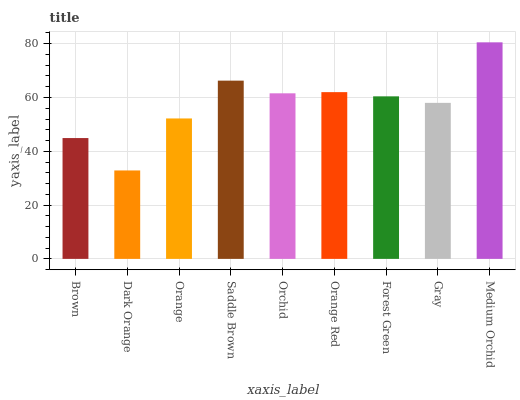Is Dark Orange the minimum?
Answer yes or no. Yes. Is Medium Orchid the maximum?
Answer yes or no. Yes. Is Orange the minimum?
Answer yes or no. No. Is Orange the maximum?
Answer yes or no. No. Is Orange greater than Dark Orange?
Answer yes or no. Yes. Is Dark Orange less than Orange?
Answer yes or no. Yes. Is Dark Orange greater than Orange?
Answer yes or no. No. Is Orange less than Dark Orange?
Answer yes or no. No. Is Forest Green the high median?
Answer yes or no. Yes. Is Forest Green the low median?
Answer yes or no. Yes. Is Orange the high median?
Answer yes or no. No. Is Orchid the low median?
Answer yes or no. No. 